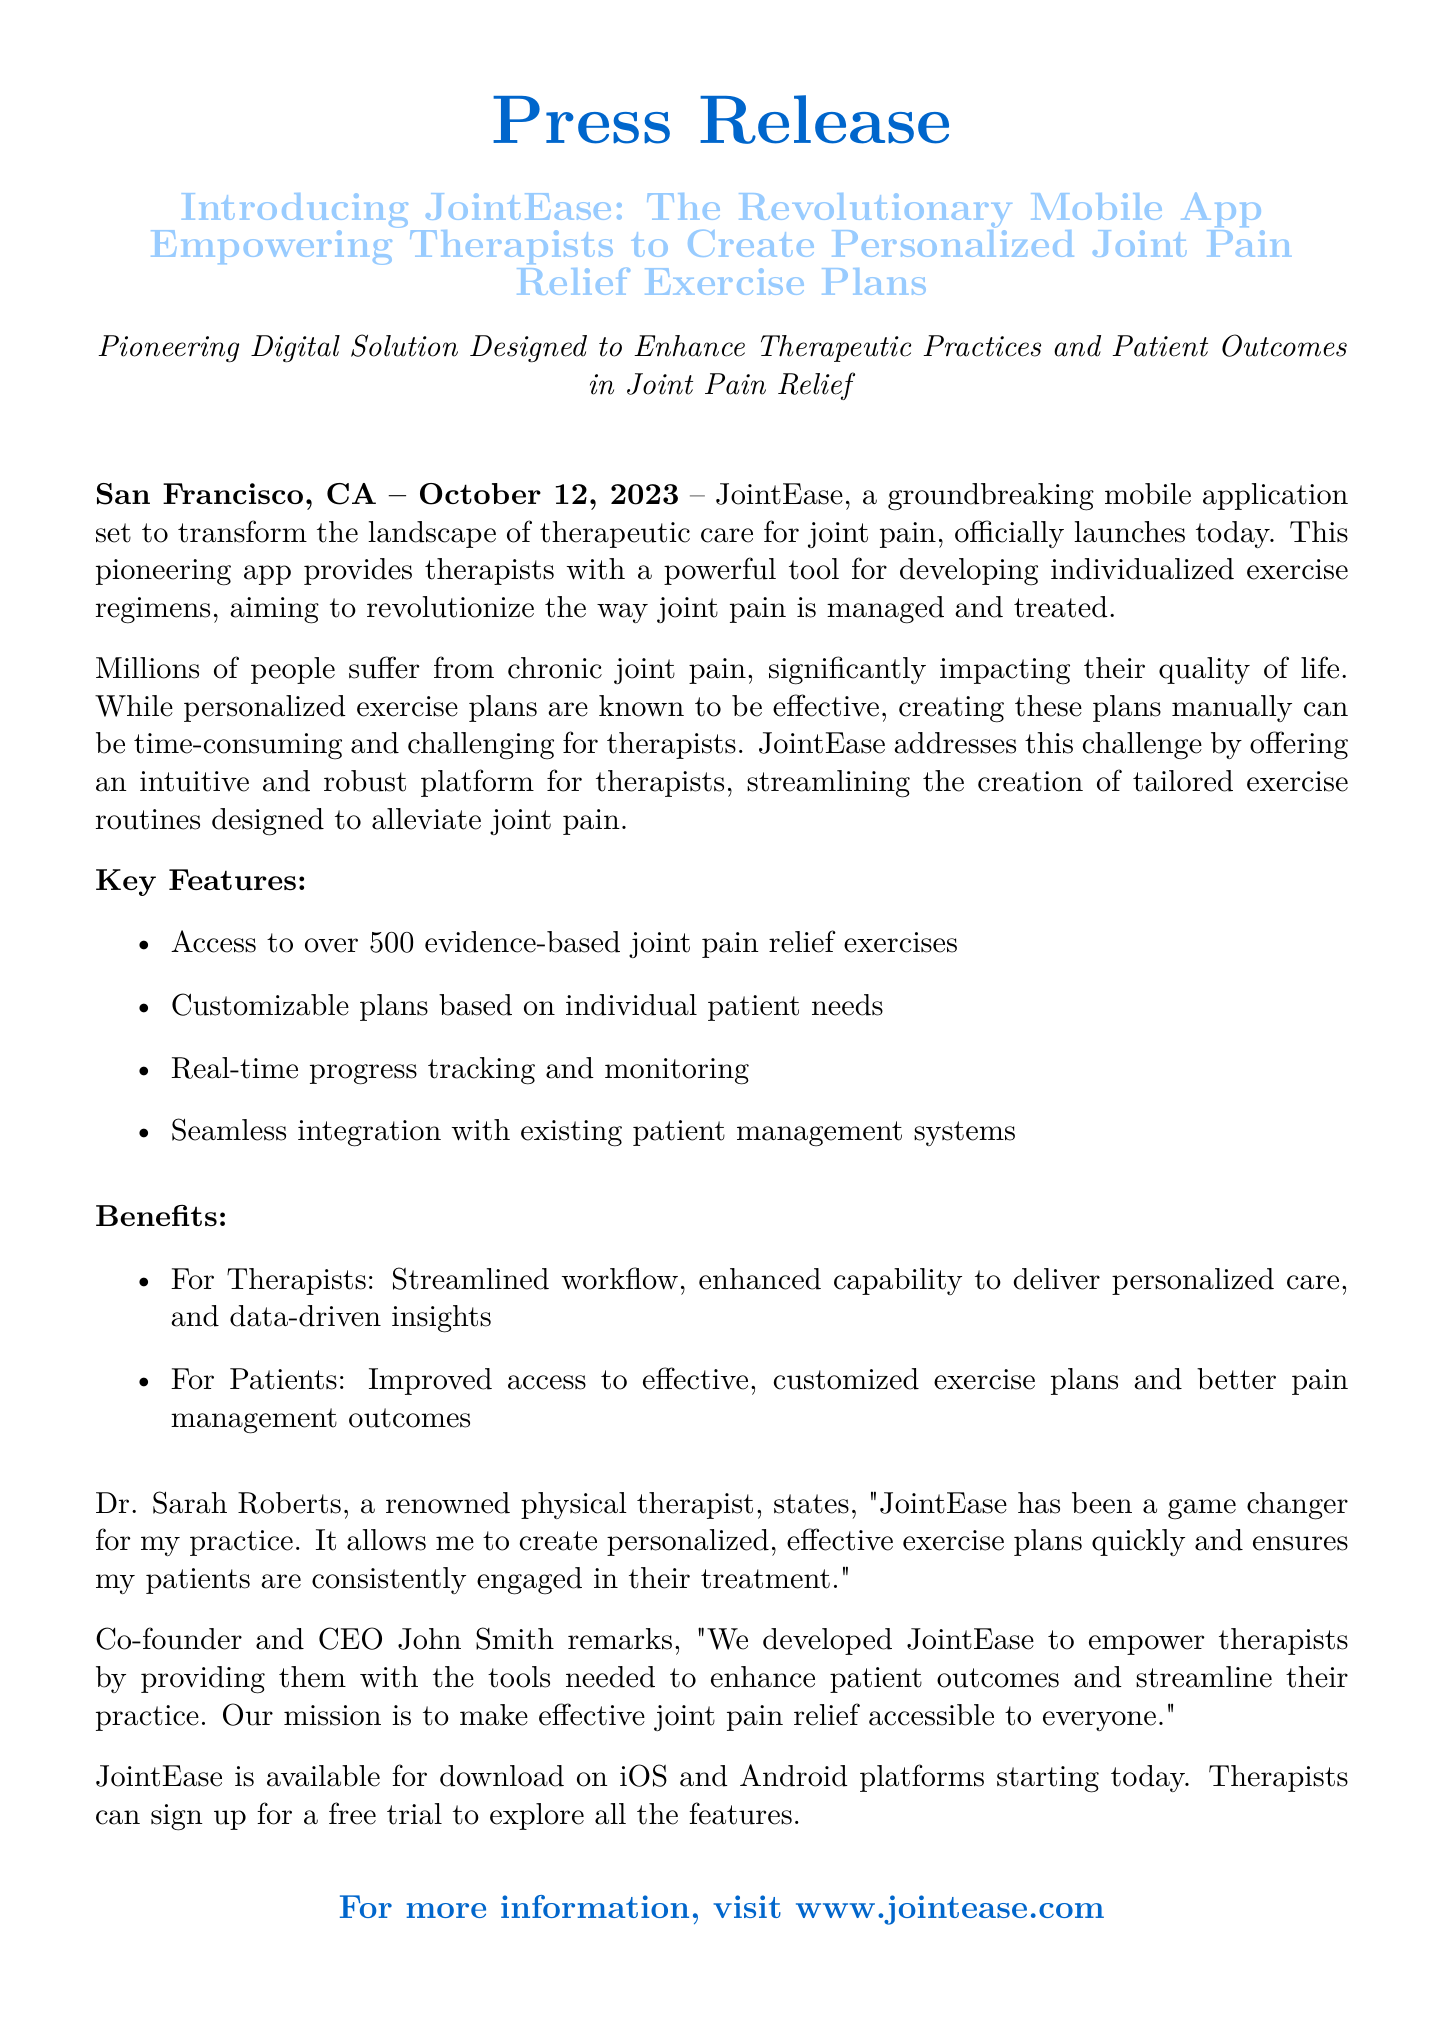What is the name of the app? The name of the app is introduced in the headline of the press release.
Answer: JointEase When was JointEase officially launched? The launch date is explicitly stated in the document.
Answer: October 12, 2023 How many exercises are available in JointEase? The document specifies the number of exercises available in the app.
Answer: 500 Who is the co-founder and CEO of JointEase? The CEO's name is mentioned in the quote from the co-founder.
Answer: John Smith What is one benefit for therapists mentioned in the document? The document lists benefits for therapists, specifying one is improved workflow.
Answer: Streamlined workflow Which platforms is JointEase available on? The platforms are listed in the announcement of the app's availability.
Answer: iOS and Android What is the main purpose of the JointEase app? The main goal of the app is highlighted in the introduction of the press release.
Answer: Alleviate joint pain Who provided a testimonial about the app? The document includes a testimonial from a specific person.
Answer: Dr. Sarah Roberts What type of system does JointEase integrate with? The document specifies what kind of system the app integrates with.
Answer: Patient management systems 